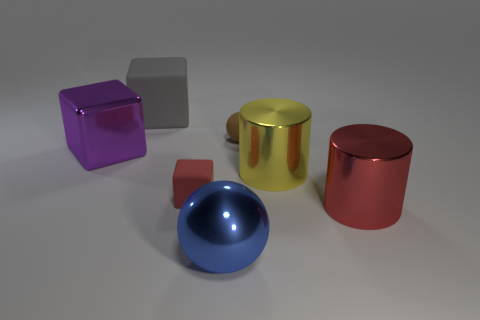Add 2 metallic cubes. How many objects exist? 9 Subtract all cylinders. How many objects are left? 5 Add 3 small purple metallic cylinders. How many small purple metallic cylinders exist? 3 Subtract 0 blue cubes. How many objects are left? 7 Subtract all yellow objects. Subtract all purple metal cubes. How many objects are left? 5 Add 1 big yellow cylinders. How many big yellow cylinders are left? 2 